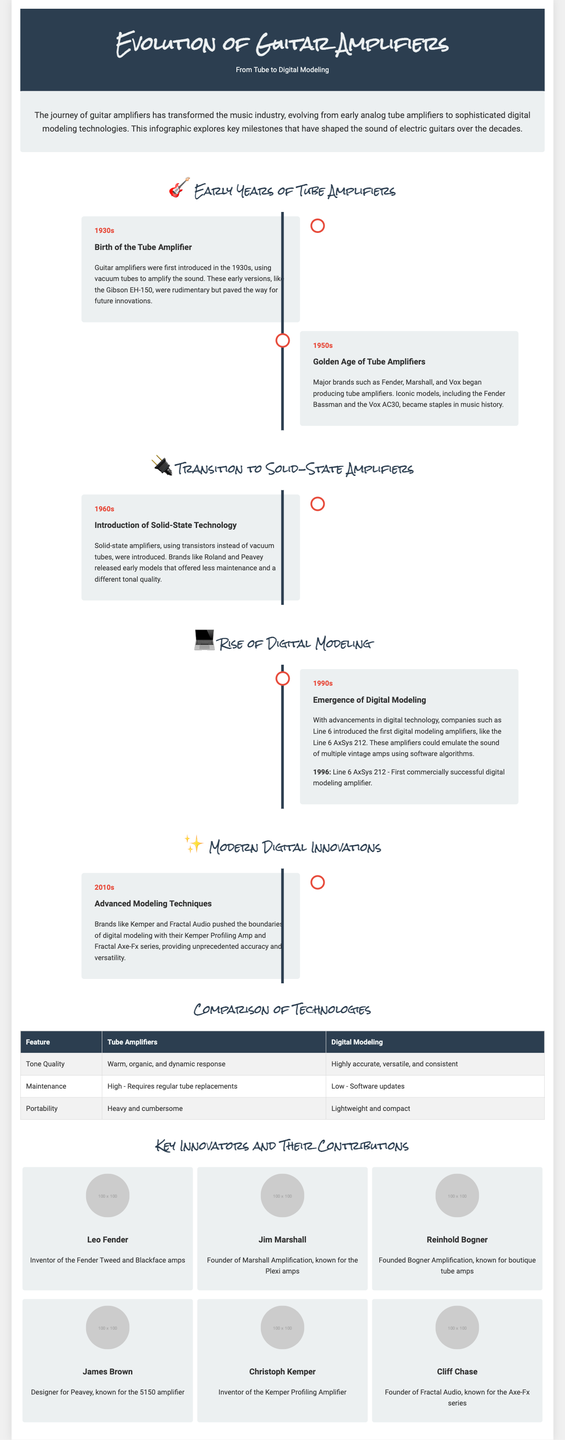What year did the first tube amplifier emerge? The first tube amplifier was introduced in the 1930s, as stated in the timeline.
Answer: 1930s What is the name of the first commercially successful digital modeling amplifier? The first commercially successful digital modeling amplifier was the Line 6 AxSys 212, introduced in 1996.
Answer: Line 6 AxSys 212 Who invented the Kemper Profiling Amplifier? Christoph Kemper is credited with inventing the Kemper Profiling Amplifier, as mentioned in the key innovators section.
Answer: Christoph Kemper What major brands began producing tube amplifiers in the 1950s? The document lists Fender, Marshall, and Vox as major brands that started producing tube amplifiers in the 1950s.
Answer: Fender, Marshall, Vox What are the two main types of amplifiers compared in the document? The document compares tube amplifiers and digital modeling amplifiers.
Answer: Tube amplifiers and digital modeling amplifiers Which decade saw the introduction of solid-state technology? The introduction of solid-state technology occurred in the 1960s, as indicated in the timeline.
Answer: 1960s What aspect of tube amplifiers is highlighted in the comparison chart regarding tone quality? The comparison chart notes that tube amplifiers are characterized by a warm, organic, and dynamic response in terms of tone quality.
Answer: Warm, organic, and dynamic response Which innovator is known for the 5150 amplifier? The document states that James Brown is known for designing the 5150 amplifier for Peavey.
Answer: James Brown 